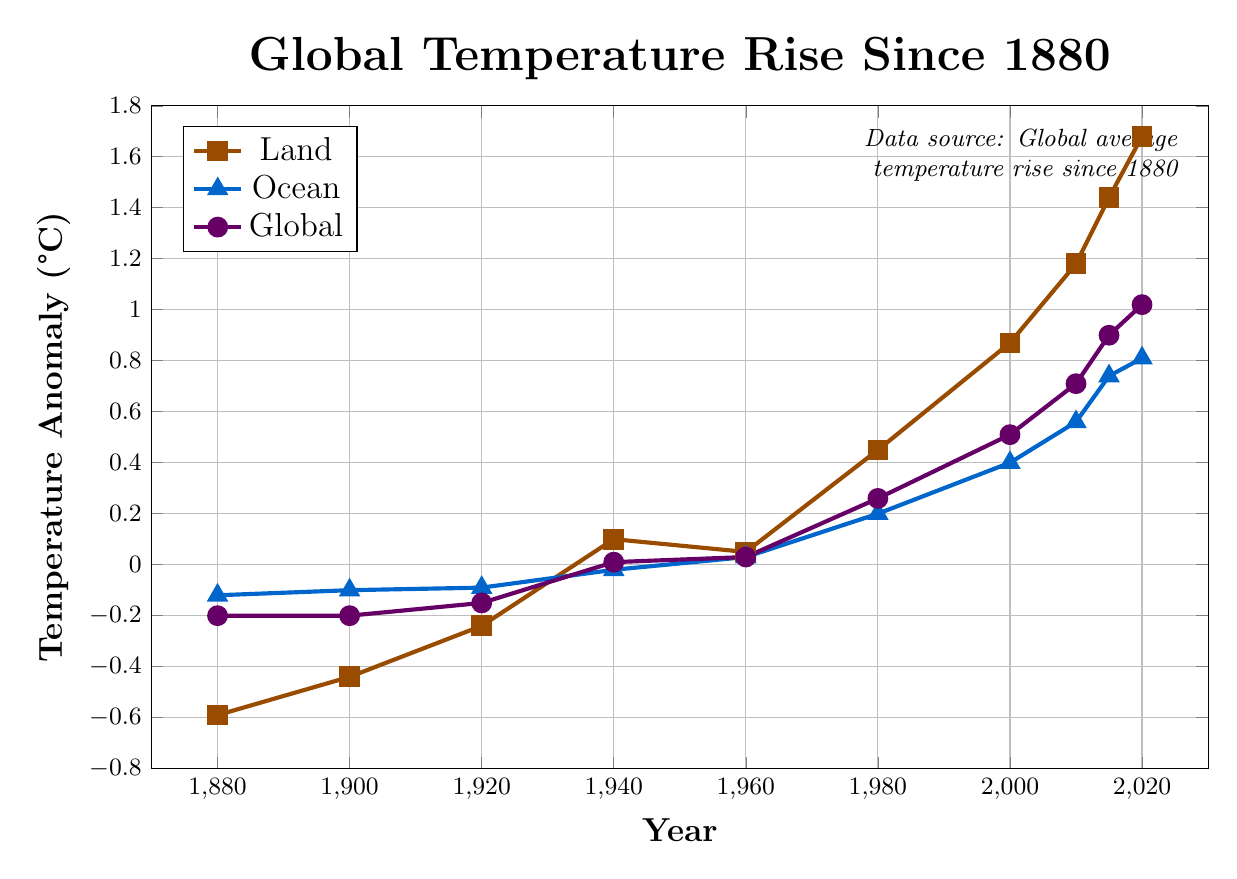What's the highest temperature anomaly recorded for land? The highest temperature anomaly for land can be observed at the peak of the 'Land' plot line. The highest value is at the year 2020. By observing the anomaly value on the y-axis, we see that it is 1.68°C.
Answer: 1.68°C Which temperature anomaly was higher in 1980, land or ocean? To determine which was higher, refer to the y-values of the land and ocean temperature anomalies at the year 1980. The land temperature anomaly in 1980 is 0.45°C, while the ocean temperature anomaly is 0.20°C. Thus, the land temperature anomaly was higher.
Answer: Land How did the global temperature anomaly change from 1880 to 2020? To understand the change, look at the global temperature anomaly values for the years 1880 and 2020. In 1880, the anomaly was -0.20°C, and in 2020, it was 1.02°C. The change can be calculated as 1.02 - (-0.20) = 1.22°C increase.
Answer: 1.22°C increase Between which two consecutive decades was the largest increase in land temperature anomaly observed? To find this, observe the land temperature anomalies for each decade. Calculate the differences between consecutive decades: 
- 1880 to 1900: -0.44 - (-0.59) = 0.15°C
- 1900 to 1920: -0.24 - (-0.44) = 0.20°C
- 1920 to 1940: 0.10 - (-0.24) = 0.34°C
- 1940 to 1960: 0.05 - 0.10 = -0.05°C
- 1960 to 1980: 0.45 - 0.05 = 0.40°C
- 1980 to 2000: 0.87 - 0.45 = 0.42°C
- 2000 to 2010: 1.18 - 0.87 = 0.31°C
- 2010 to 2015: 1.44 - 1.18 = 0.26°C
- 2015 to 2020: 1.68 - 1.44 = 0.24°C
The largest increase is from 1980 to 2000 with 0.42°C.
Answer: 1980 to 2000 What is the temperature anomaly trend for the ocean from 1880 to 2020? Look at the plotted data points for ocean temperatures from 1880 to 2020. Observing the trend, it generally increases. It starts at -0.12°C in 1880 and rises to 0.81°C by 2020, indicating an increasing trend in ocean temperature anomalies.
Answer: Increasing By how much did the global temperature anomaly increase between 1940 and 2020 when considering the anomaly values in the plot? Find the global temperature anomaly values for the years 1940 and 2020. For 1940, it is 0.01°C, and for 2020, it is 1.02°C. The increase is calculated as 1.02 - 0.01 = 1.01°C.
Answer: 1.01°C Which year had the smaller ocean temperature anomaly, 1920 or 1960? Check the y-values for ocean temperature anomalies in the years 1920 and 1960. In 1920, it is -0.09°C, and in 1960, it is 0.03°C. Therefore, 1920 had the smaller anomaly.
Answer: 1920 What was the global temperature anomaly relative difference between 2000 and 2010? To find the relative difference, measure the difference between the anomalies and then divide by the value in 2000. For 2000, it's 0.51°C, and for 2010, it's 0.71°C. The difference is 0.71 - 0.51 = 0.20°C. The relative difference is (0.20 / 0.51) = 0.392 or 39.2%.
Answer: 39.2% When did the land temperature anomaly first exceed 0.50°C? Focus on the point where the land temperature anomaly crosses 0.50°C. This happens between 1960 and 1980, specifically it happens in 1980 when the value is 0.45°C. So, the earliest time it exceeds 0.50°C would be after 1980. The increase above 0.50°C can be precisely seen in the year 2000, which is 0.87°C.
Answer: 2000 Overall, do land or ocean temperatures show a sharper increase over the historical period? Compare the rise in temperature anomalies for land and ocean from 1880 to 2020. Land temperature anomaly increases from -0.59°C to 1.68°C (an increase of 2.27°C), whereas the ocean temperature anomaly rises from -0.12°C to 0.81°C (an increase of 0.93°C). The land temperatures show a sharper increase.
Answer: Land 